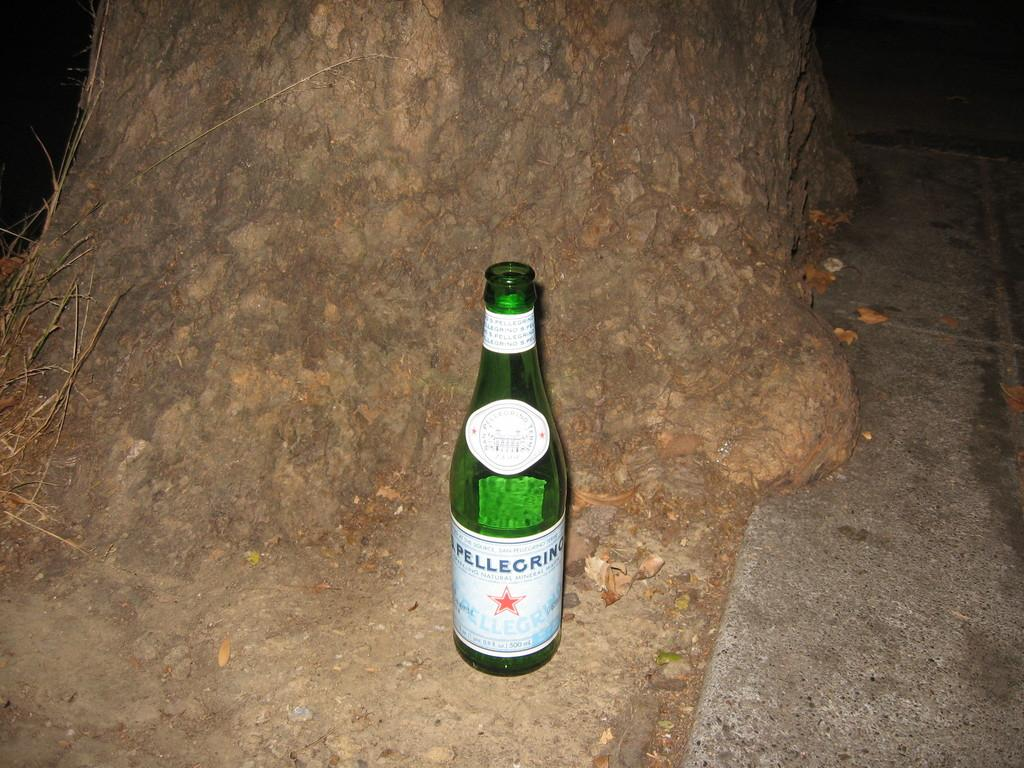<image>
Offer a succinct explanation of the picture presented. Bottle of pellegrino on the ground beside a tree. 